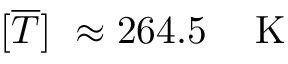Convert formula to latex. <formula><loc_0><loc_0><loc_500><loc_500>[ \overline { T } ] \approx 2 6 4 . 5 \, K</formula> 